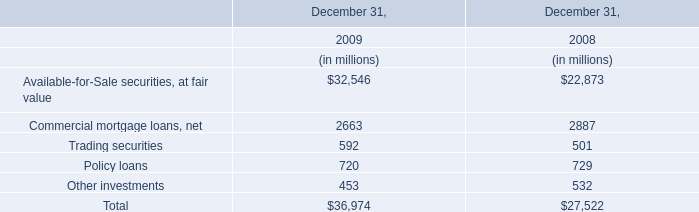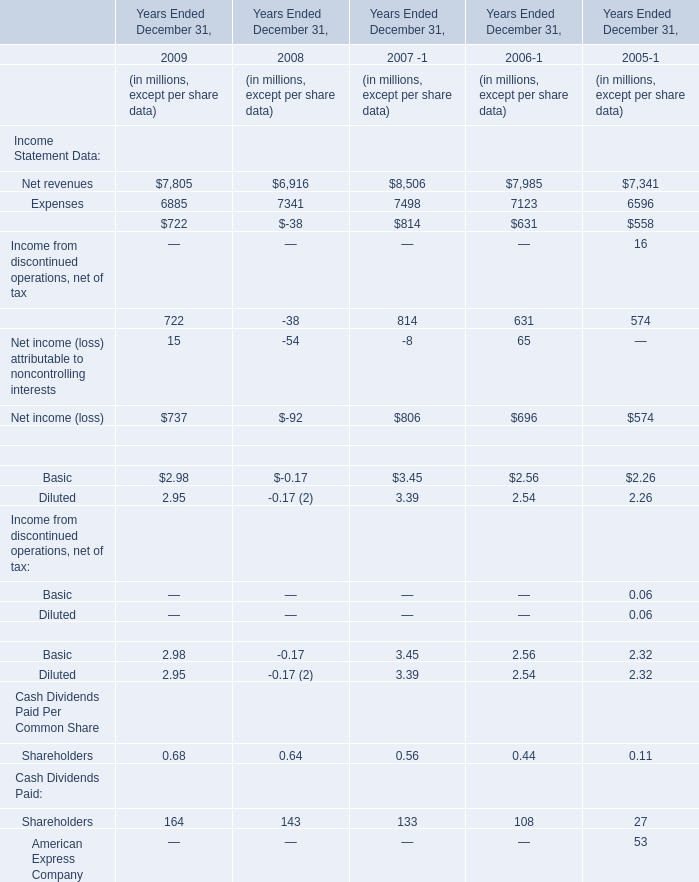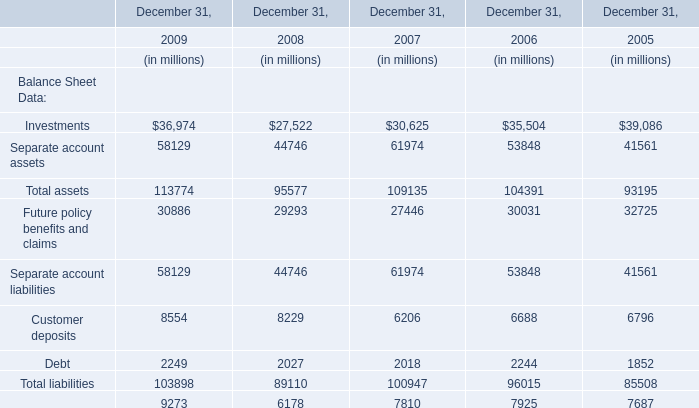What's the average of Expenses and Net revenues in 2009? (in million) 
Computations: ((7805 + 6885) / 2)
Answer: 7345.0. 